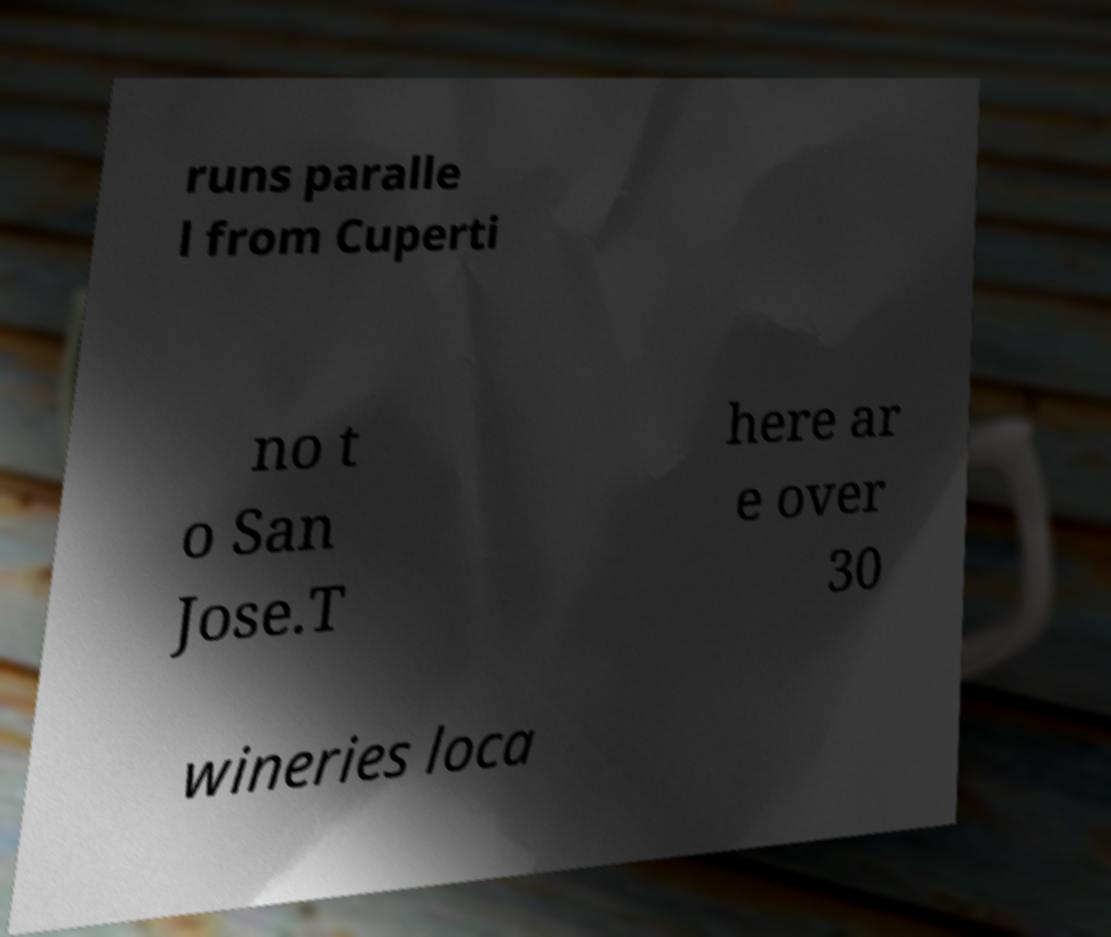Please read and relay the text visible in this image. What does it say? runs paralle l from Cuperti no t o San Jose.T here ar e over 30 wineries loca 